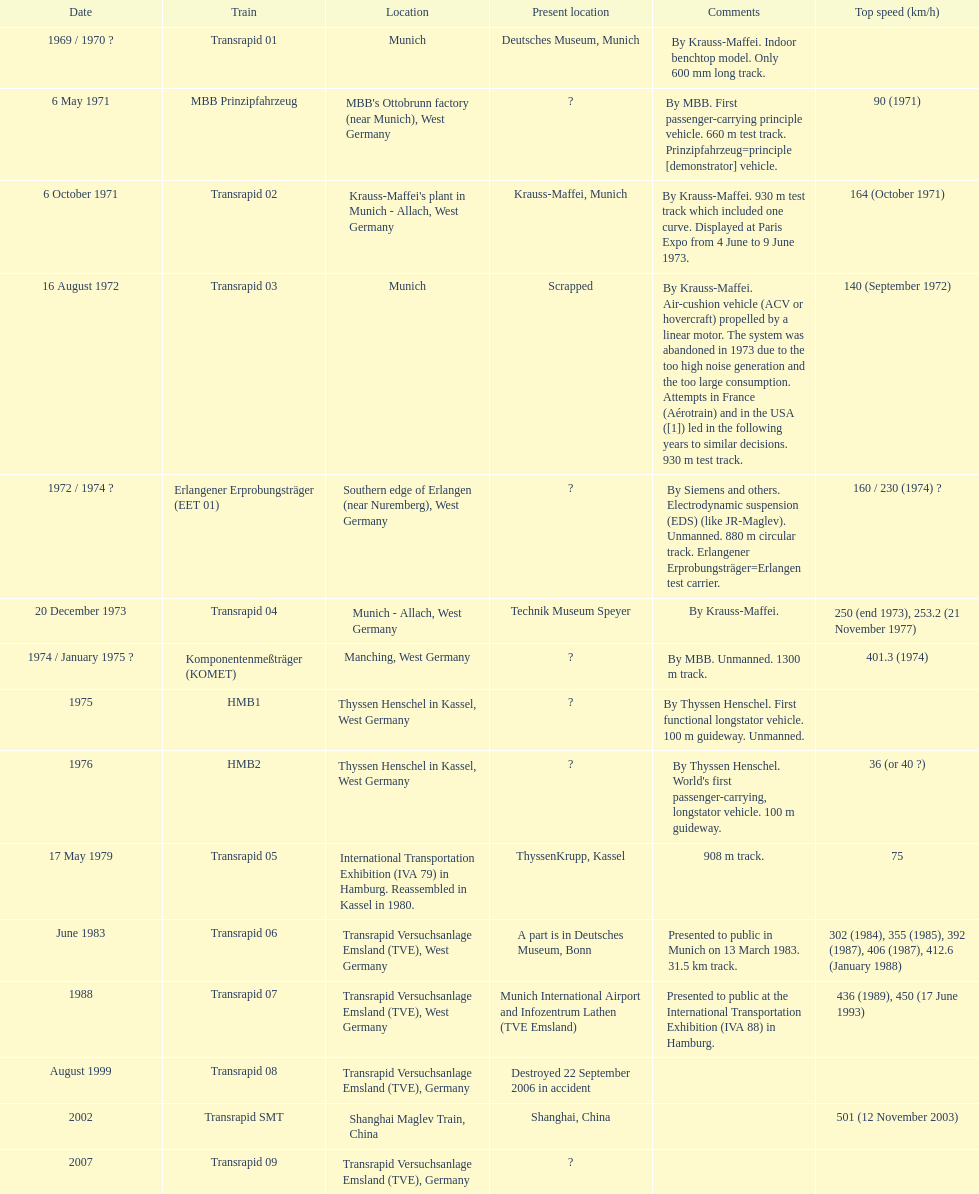Excessive noise production and substantial consumption resulted in which train being discarded? Transrapid 03. 